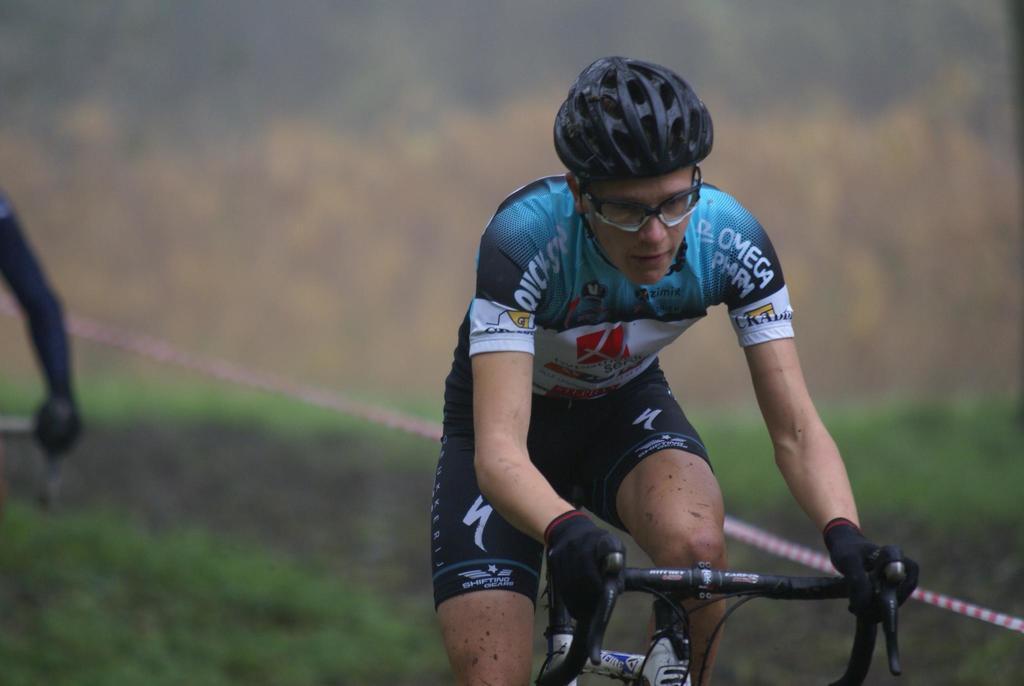Describe this image in one or two sentences. In this image, we can see a person riding a bicycle. This person is wearing clothes and helmet. In the background, image is blurred. 